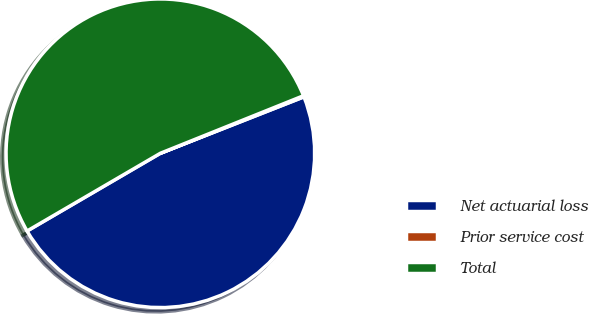Convert chart. <chart><loc_0><loc_0><loc_500><loc_500><pie_chart><fcel>Net actuarial loss<fcel>Prior service cost<fcel>Total<nl><fcel>47.56%<fcel>0.12%<fcel>52.32%<nl></chart> 